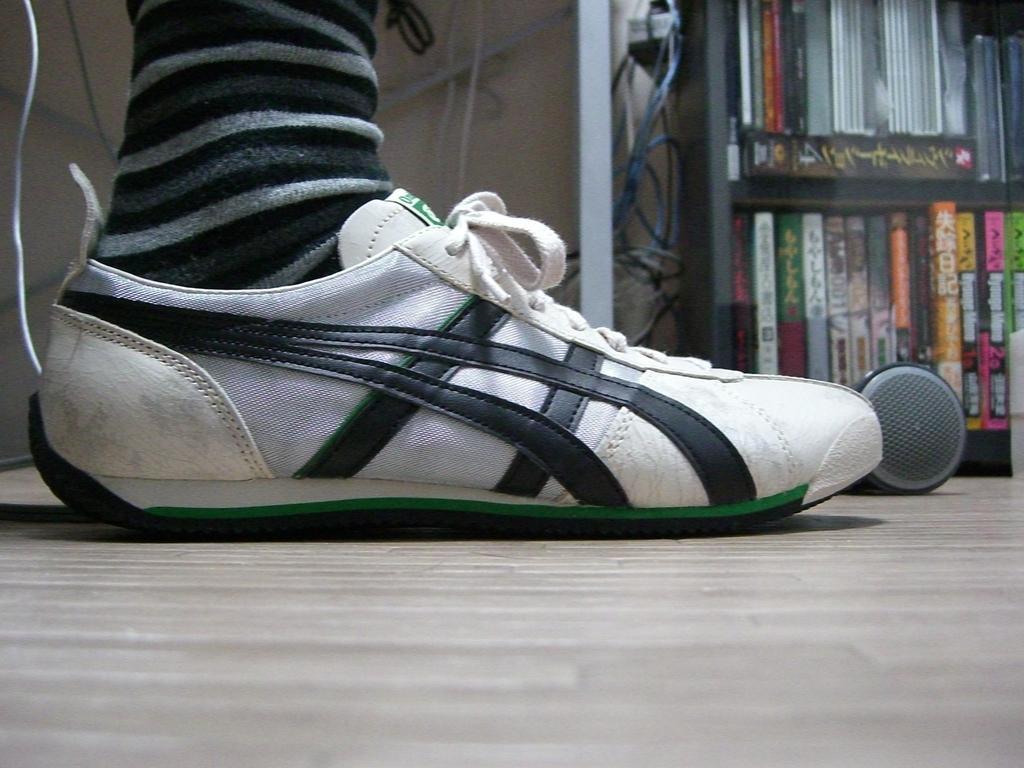Could you give a brief overview of what you see in this image? In this image I can see a person shoes visible on the floor, in the top right I can see books kept in the rack. 